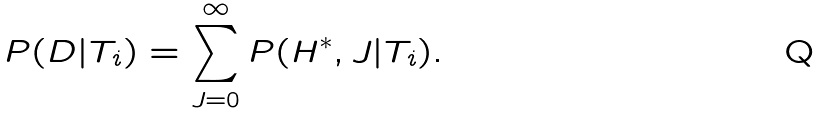<formula> <loc_0><loc_0><loc_500><loc_500>P ( D | T _ { i } ) = \sum _ { J = 0 } ^ { \infty } P ( { H ^ { * } } , J | T _ { i } ) .</formula> 